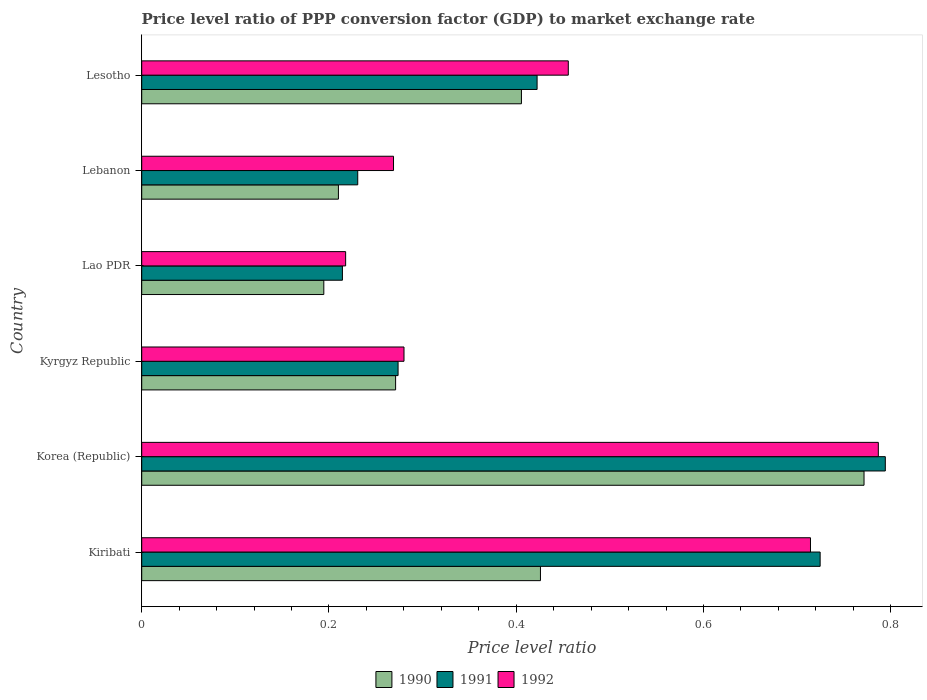How many different coloured bars are there?
Offer a terse response. 3. How many groups of bars are there?
Keep it short and to the point. 6. How many bars are there on the 3rd tick from the top?
Offer a terse response. 3. How many bars are there on the 1st tick from the bottom?
Give a very brief answer. 3. What is the label of the 6th group of bars from the top?
Offer a terse response. Kiribati. What is the price level ratio in 1992 in Lao PDR?
Keep it short and to the point. 0.22. Across all countries, what is the maximum price level ratio in 1992?
Ensure brevity in your answer.  0.79. Across all countries, what is the minimum price level ratio in 1991?
Your response must be concise. 0.21. In which country was the price level ratio in 1992 maximum?
Make the answer very short. Korea (Republic). In which country was the price level ratio in 1992 minimum?
Your answer should be very brief. Lao PDR. What is the total price level ratio in 1992 in the graph?
Offer a very short reply. 2.72. What is the difference between the price level ratio in 1990 in Lao PDR and that in Lesotho?
Give a very brief answer. -0.21. What is the difference between the price level ratio in 1992 in Kyrgyz Republic and the price level ratio in 1991 in Korea (Republic)?
Give a very brief answer. -0.51. What is the average price level ratio in 1991 per country?
Your answer should be compact. 0.44. What is the difference between the price level ratio in 1991 and price level ratio in 1992 in Lesotho?
Offer a very short reply. -0.03. What is the ratio of the price level ratio in 1992 in Kyrgyz Republic to that in Lebanon?
Your answer should be compact. 1.04. Is the price level ratio in 1991 in Kyrgyz Republic less than that in Lao PDR?
Your answer should be compact. No. Is the difference between the price level ratio in 1991 in Kyrgyz Republic and Lesotho greater than the difference between the price level ratio in 1992 in Kyrgyz Republic and Lesotho?
Your answer should be compact. Yes. What is the difference between the highest and the second highest price level ratio in 1990?
Provide a succinct answer. 0.35. What is the difference between the highest and the lowest price level ratio in 1990?
Offer a very short reply. 0.58. What does the 3rd bar from the bottom in Korea (Republic) represents?
Keep it short and to the point. 1992. How many bars are there?
Offer a terse response. 18. Are all the bars in the graph horizontal?
Give a very brief answer. Yes. How many countries are there in the graph?
Ensure brevity in your answer.  6. What is the difference between two consecutive major ticks on the X-axis?
Provide a succinct answer. 0.2. Does the graph contain any zero values?
Your answer should be compact. No. Does the graph contain grids?
Give a very brief answer. No. What is the title of the graph?
Provide a succinct answer. Price level ratio of PPP conversion factor (GDP) to market exchange rate. Does "1992" appear as one of the legend labels in the graph?
Your answer should be compact. Yes. What is the label or title of the X-axis?
Offer a very short reply. Price level ratio. What is the label or title of the Y-axis?
Your answer should be very brief. Country. What is the Price level ratio of 1990 in Kiribati?
Make the answer very short. 0.43. What is the Price level ratio of 1991 in Kiribati?
Offer a very short reply. 0.72. What is the Price level ratio in 1992 in Kiribati?
Give a very brief answer. 0.71. What is the Price level ratio of 1990 in Korea (Republic)?
Keep it short and to the point. 0.77. What is the Price level ratio in 1991 in Korea (Republic)?
Keep it short and to the point. 0.79. What is the Price level ratio in 1992 in Korea (Republic)?
Your response must be concise. 0.79. What is the Price level ratio in 1990 in Kyrgyz Republic?
Your answer should be very brief. 0.27. What is the Price level ratio of 1991 in Kyrgyz Republic?
Give a very brief answer. 0.27. What is the Price level ratio of 1992 in Kyrgyz Republic?
Provide a short and direct response. 0.28. What is the Price level ratio of 1990 in Lao PDR?
Provide a succinct answer. 0.19. What is the Price level ratio of 1991 in Lao PDR?
Provide a short and direct response. 0.21. What is the Price level ratio of 1992 in Lao PDR?
Your answer should be very brief. 0.22. What is the Price level ratio of 1990 in Lebanon?
Make the answer very short. 0.21. What is the Price level ratio of 1991 in Lebanon?
Ensure brevity in your answer.  0.23. What is the Price level ratio of 1992 in Lebanon?
Give a very brief answer. 0.27. What is the Price level ratio in 1990 in Lesotho?
Ensure brevity in your answer.  0.41. What is the Price level ratio in 1991 in Lesotho?
Offer a very short reply. 0.42. What is the Price level ratio of 1992 in Lesotho?
Provide a succinct answer. 0.46. Across all countries, what is the maximum Price level ratio in 1990?
Offer a terse response. 0.77. Across all countries, what is the maximum Price level ratio in 1991?
Keep it short and to the point. 0.79. Across all countries, what is the maximum Price level ratio in 1992?
Offer a very short reply. 0.79. Across all countries, what is the minimum Price level ratio in 1990?
Your response must be concise. 0.19. Across all countries, what is the minimum Price level ratio in 1991?
Keep it short and to the point. 0.21. Across all countries, what is the minimum Price level ratio of 1992?
Provide a succinct answer. 0.22. What is the total Price level ratio of 1990 in the graph?
Your answer should be compact. 2.28. What is the total Price level ratio in 1991 in the graph?
Ensure brevity in your answer.  2.66. What is the total Price level ratio of 1992 in the graph?
Your response must be concise. 2.72. What is the difference between the Price level ratio in 1990 in Kiribati and that in Korea (Republic)?
Offer a very short reply. -0.35. What is the difference between the Price level ratio in 1991 in Kiribati and that in Korea (Republic)?
Keep it short and to the point. -0.07. What is the difference between the Price level ratio in 1992 in Kiribati and that in Korea (Republic)?
Offer a very short reply. -0.07. What is the difference between the Price level ratio in 1990 in Kiribati and that in Kyrgyz Republic?
Ensure brevity in your answer.  0.15. What is the difference between the Price level ratio in 1991 in Kiribati and that in Kyrgyz Republic?
Make the answer very short. 0.45. What is the difference between the Price level ratio in 1992 in Kiribati and that in Kyrgyz Republic?
Offer a terse response. 0.43. What is the difference between the Price level ratio of 1990 in Kiribati and that in Lao PDR?
Your answer should be compact. 0.23. What is the difference between the Price level ratio of 1991 in Kiribati and that in Lao PDR?
Give a very brief answer. 0.51. What is the difference between the Price level ratio in 1992 in Kiribati and that in Lao PDR?
Keep it short and to the point. 0.5. What is the difference between the Price level ratio of 1990 in Kiribati and that in Lebanon?
Make the answer very short. 0.22. What is the difference between the Price level ratio in 1991 in Kiribati and that in Lebanon?
Provide a succinct answer. 0.49. What is the difference between the Price level ratio of 1992 in Kiribati and that in Lebanon?
Make the answer very short. 0.45. What is the difference between the Price level ratio of 1990 in Kiribati and that in Lesotho?
Your answer should be compact. 0.02. What is the difference between the Price level ratio in 1991 in Kiribati and that in Lesotho?
Provide a short and direct response. 0.3. What is the difference between the Price level ratio in 1992 in Kiribati and that in Lesotho?
Your response must be concise. 0.26. What is the difference between the Price level ratio of 1990 in Korea (Republic) and that in Kyrgyz Republic?
Your answer should be very brief. 0.5. What is the difference between the Price level ratio of 1991 in Korea (Republic) and that in Kyrgyz Republic?
Provide a short and direct response. 0.52. What is the difference between the Price level ratio of 1992 in Korea (Republic) and that in Kyrgyz Republic?
Give a very brief answer. 0.51. What is the difference between the Price level ratio in 1990 in Korea (Republic) and that in Lao PDR?
Your response must be concise. 0.58. What is the difference between the Price level ratio in 1991 in Korea (Republic) and that in Lao PDR?
Your answer should be very brief. 0.58. What is the difference between the Price level ratio of 1992 in Korea (Republic) and that in Lao PDR?
Make the answer very short. 0.57. What is the difference between the Price level ratio in 1990 in Korea (Republic) and that in Lebanon?
Offer a terse response. 0.56. What is the difference between the Price level ratio of 1991 in Korea (Republic) and that in Lebanon?
Your answer should be very brief. 0.56. What is the difference between the Price level ratio of 1992 in Korea (Republic) and that in Lebanon?
Ensure brevity in your answer.  0.52. What is the difference between the Price level ratio of 1990 in Korea (Republic) and that in Lesotho?
Provide a short and direct response. 0.37. What is the difference between the Price level ratio in 1991 in Korea (Republic) and that in Lesotho?
Ensure brevity in your answer.  0.37. What is the difference between the Price level ratio in 1992 in Korea (Republic) and that in Lesotho?
Offer a terse response. 0.33. What is the difference between the Price level ratio in 1990 in Kyrgyz Republic and that in Lao PDR?
Your answer should be very brief. 0.08. What is the difference between the Price level ratio in 1991 in Kyrgyz Republic and that in Lao PDR?
Your answer should be compact. 0.06. What is the difference between the Price level ratio in 1992 in Kyrgyz Republic and that in Lao PDR?
Keep it short and to the point. 0.06. What is the difference between the Price level ratio in 1990 in Kyrgyz Republic and that in Lebanon?
Offer a very short reply. 0.06. What is the difference between the Price level ratio of 1991 in Kyrgyz Republic and that in Lebanon?
Offer a very short reply. 0.04. What is the difference between the Price level ratio of 1992 in Kyrgyz Republic and that in Lebanon?
Offer a very short reply. 0.01. What is the difference between the Price level ratio of 1990 in Kyrgyz Republic and that in Lesotho?
Make the answer very short. -0.13. What is the difference between the Price level ratio in 1991 in Kyrgyz Republic and that in Lesotho?
Offer a very short reply. -0.15. What is the difference between the Price level ratio of 1992 in Kyrgyz Republic and that in Lesotho?
Make the answer very short. -0.18. What is the difference between the Price level ratio in 1990 in Lao PDR and that in Lebanon?
Your answer should be compact. -0.02. What is the difference between the Price level ratio in 1991 in Lao PDR and that in Lebanon?
Ensure brevity in your answer.  -0.02. What is the difference between the Price level ratio of 1992 in Lao PDR and that in Lebanon?
Offer a very short reply. -0.05. What is the difference between the Price level ratio of 1990 in Lao PDR and that in Lesotho?
Provide a succinct answer. -0.21. What is the difference between the Price level ratio in 1991 in Lao PDR and that in Lesotho?
Keep it short and to the point. -0.21. What is the difference between the Price level ratio of 1992 in Lao PDR and that in Lesotho?
Provide a short and direct response. -0.24. What is the difference between the Price level ratio of 1990 in Lebanon and that in Lesotho?
Give a very brief answer. -0.2. What is the difference between the Price level ratio in 1991 in Lebanon and that in Lesotho?
Provide a short and direct response. -0.19. What is the difference between the Price level ratio in 1992 in Lebanon and that in Lesotho?
Provide a succinct answer. -0.19. What is the difference between the Price level ratio of 1990 in Kiribati and the Price level ratio of 1991 in Korea (Republic)?
Give a very brief answer. -0.37. What is the difference between the Price level ratio in 1990 in Kiribati and the Price level ratio in 1992 in Korea (Republic)?
Offer a very short reply. -0.36. What is the difference between the Price level ratio of 1991 in Kiribati and the Price level ratio of 1992 in Korea (Republic)?
Offer a very short reply. -0.06. What is the difference between the Price level ratio of 1990 in Kiribati and the Price level ratio of 1991 in Kyrgyz Republic?
Your answer should be very brief. 0.15. What is the difference between the Price level ratio of 1990 in Kiribati and the Price level ratio of 1992 in Kyrgyz Republic?
Your response must be concise. 0.15. What is the difference between the Price level ratio in 1991 in Kiribati and the Price level ratio in 1992 in Kyrgyz Republic?
Ensure brevity in your answer.  0.44. What is the difference between the Price level ratio of 1990 in Kiribati and the Price level ratio of 1991 in Lao PDR?
Provide a succinct answer. 0.21. What is the difference between the Price level ratio in 1990 in Kiribati and the Price level ratio in 1992 in Lao PDR?
Your answer should be compact. 0.21. What is the difference between the Price level ratio in 1991 in Kiribati and the Price level ratio in 1992 in Lao PDR?
Give a very brief answer. 0.51. What is the difference between the Price level ratio of 1990 in Kiribati and the Price level ratio of 1991 in Lebanon?
Keep it short and to the point. 0.2. What is the difference between the Price level ratio of 1990 in Kiribati and the Price level ratio of 1992 in Lebanon?
Keep it short and to the point. 0.16. What is the difference between the Price level ratio of 1991 in Kiribati and the Price level ratio of 1992 in Lebanon?
Provide a succinct answer. 0.46. What is the difference between the Price level ratio in 1990 in Kiribati and the Price level ratio in 1991 in Lesotho?
Your response must be concise. 0. What is the difference between the Price level ratio of 1990 in Kiribati and the Price level ratio of 1992 in Lesotho?
Your answer should be compact. -0.03. What is the difference between the Price level ratio in 1991 in Kiribati and the Price level ratio in 1992 in Lesotho?
Make the answer very short. 0.27. What is the difference between the Price level ratio in 1990 in Korea (Republic) and the Price level ratio in 1991 in Kyrgyz Republic?
Provide a short and direct response. 0.5. What is the difference between the Price level ratio in 1990 in Korea (Republic) and the Price level ratio in 1992 in Kyrgyz Republic?
Your answer should be very brief. 0.49. What is the difference between the Price level ratio of 1991 in Korea (Republic) and the Price level ratio of 1992 in Kyrgyz Republic?
Provide a succinct answer. 0.51. What is the difference between the Price level ratio of 1990 in Korea (Republic) and the Price level ratio of 1991 in Lao PDR?
Make the answer very short. 0.56. What is the difference between the Price level ratio of 1990 in Korea (Republic) and the Price level ratio of 1992 in Lao PDR?
Your answer should be very brief. 0.55. What is the difference between the Price level ratio in 1991 in Korea (Republic) and the Price level ratio in 1992 in Lao PDR?
Offer a terse response. 0.58. What is the difference between the Price level ratio of 1990 in Korea (Republic) and the Price level ratio of 1991 in Lebanon?
Give a very brief answer. 0.54. What is the difference between the Price level ratio of 1990 in Korea (Republic) and the Price level ratio of 1992 in Lebanon?
Keep it short and to the point. 0.5. What is the difference between the Price level ratio of 1991 in Korea (Republic) and the Price level ratio of 1992 in Lebanon?
Your answer should be very brief. 0.53. What is the difference between the Price level ratio of 1990 in Korea (Republic) and the Price level ratio of 1991 in Lesotho?
Give a very brief answer. 0.35. What is the difference between the Price level ratio in 1990 in Korea (Republic) and the Price level ratio in 1992 in Lesotho?
Your answer should be compact. 0.32. What is the difference between the Price level ratio in 1991 in Korea (Republic) and the Price level ratio in 1992 in Lesotho?
Offer a terse response. 0.34. What is the difference between the Price level ratio in 1990 in Kyrgyz Republic and the Price level ratio in 1991 in Lao PDR?
Keep it short and to the point. 0.06. What is the difference between the Price level ratio of 1990 in Kyrgyz Republic and the Price level ratio of 1992 in Lao PDR?
Your response must be concise. 0.05. What is the difference between the Price level ratio in 1991 in Kyrgyz Republic and the Price level ratio in 1992 in Lao PDR?
Keep it short and to the point. 0.06. What is the difference between the Price level ratio of 1990 in Kyrgyz Republic and the Price level ratio of 1991 in Lebanon?
Give a very brief answer. 0.04. What is the difference between the Price level ratio of 1990 in Kyrgyz Republic and the Price level ratio of 1992 in Lebanon?
Make the answer very short. 0. What is the difference between the Price level ratio of 1991 in Kyrgyz Republic and the Price level ratio of 1992 in Lebanon?
Offer a very short reply. 0. What is the difference between the Price level ratio of 1990 in Kyrgyz Republic and the Price level ratio of 1991 in Lesotho?
Keep it short and to the point. -0.15. What is the difference between the Price level ratio of 1990 in Kyrgyz Republic and the Price level ratio of 1992 in Lesotho?
Provide a succinct answer. -0.18. What is the difference between the Price level ratio in 1991 in Kyrgyz Republic and the Price level ratio in 1992 in Lesotho?
Provide a short and direct response. -0.18. What is the difference between the Price level ratio of 1990 in Lao PDR and the Price level ratio of 1991 in Lebanon?
Provide a short and direct response. -0.04. What is the difference between the Price level ratio in 1990 in Lao PDR and the Price level ratio in 1992 in Lebanon?
Provide a succinct answer. -0.07. What is the difference between the Price level ratio in 1991 in Lao PDR and the Price level ratio in 1992 in Lebanon?
Your answer should be very brief. -0.05. What is the difference between the Price level ratio of 1990 in Lao PDR and the Price level ratio of 1991 in Lesotho?
Keep it short and to the point. -0.23. What is the difference between the Price level ratio of 1990 in Lao PDR and the Price level ratio of 1992 in Lesotho?
Offer a very short reply. -0.26. What is the difference between the Price level ratio of 1991 in Lao PDR and the Price level ratio of 1992 in Lesotho?
Your answer should be compact. -0.24. What is the difference between the Price level ratio in 1990 in Lebanon and the Price level ratio in 1991 in Lesotho?
Offer a terse response. -0.21. What is the difference between the Price level ratio of 1990 in Lebanon and the Price level ratio of 1992 in Lesotho?
Offer a very short reply. -0.25. What is the difference between the Price level ratio of 1991 in Lebanon and the Price level ratio of 1992 in Lesotho?
Offer a very short reply. -0.22. What is the average Price level ratio in 1990 per country?
Provide a short and direct response. 0.38. What is the average Price level ratio of 1991 per country?
Provide a succinct answer. 0.44. What is the average Price level ratio of 1992 per country?
Provide a short and direct response. 0.45. What is the difference between the Price level ratio in 1990 and Price level ratio in 1991 in Kiribati?
Your answer should be very brief. -0.3. What is the difference between the Price level ratio of 1990 and Price level ratio of 1992 in Kiribati?
Offer a terse response. -0.29. What is the difference between the Price level ratio in 1991 and Price level ratio in 1992 in Kiribati?
Your response must be concise. 0.01. What is the difference between the Price level ratio of 1990 and Price level ratio of 1991 in Korea (Republic)?
Offer a terse response. -0.02. What is the difference between the Price level ratio of 1990 and Price level ratio of 1992 in Korea (Republic)?
Your answer should be very brief. -0.02. What is the difference between the Price level ratio of 1991 and Price level ratio of 1992 in Korea (Republic)?
Provide a succinct answer. 0.01. What is the difference between the Price level ratio of 1990 and Price level ratio of 1991 in Kyrgyz Republic?
Offer a very short reply. -0. What is the difference between the Price level ratio of 1990 and Price level ratio of 1992 in Kyrgyz Republic?
Make the answer very short. -0.01. What is the difference between the Price level ratio in 1991 and Price level ratio in 1992 in Kyrgyz Republic?
Offer a terse response. -0.01. What is the difference between the Price level ratio of 1990 and Price level ratio of 1991 in Lao PDR?
Make the answer very short. -0.02. What is the difference between the Price level ratio of 1990 and Price level ratio of 1992 in Lao PDR?
Your answer should be very brief. -0.02. What is the difference between the Price level ratio in 1991 and Price level ratio in 1992 in Lao PDR?
Your response must be concise. -0. What is the difference between the Price level ratio in 1990 and Price level ratio in 1991 in Lebanon?
Make the answer very short. -0.02. What is the difference between the Price level ratio of 1990 and Price level ratio of 1992 in Lebanon?
Make the answer very short. -0.06. What is the difference between the Price level ratio in 1991 and Price level ratio in 1992 in Lebanon?
Give a very brief answer. -0.04. What is the difference between the Price level ratio of 1990 and Price level ratio of 1991 in Lesotho?
Your response must be concise. -0.02. What is the difference between the Price level ratio in 1991 and Price level ratio in 1992 in Lesotho?
Provide a short and direct response. -0.03. What is the ratio of the Price level ratio in 1990 in Kiribati to that in Korea (Republic)?
Ensure brevity in your answer.  0.55. What is the ratio of the Price level ratio in 1991 in Kiribati to that in Korea (Republic)?
Provide a short and direct response. 0.91. What is the ratio of the Price level ratio of 1992 in Kiribati to that in Korea (Republic)?
Your answer should be very brief. 0.91. What is the ratio of the Price level ratio of 1990 in Kiribati to that in Kyrgyz Republic?
Offer a very short reply. 1.57. What is the ratio of the Price level ratio of 1991 in Kiribati to that in Kyrgyz Republic?
Your answer should be compact. 2.65. What is the ratio of the Price level ratio in 1992 in Kiribati to that in Kyrgyz Republic?
Your response must be concise. 2.55. What is the ratio of the Price level ratio in 1990 in Kiribati to that in Lao PDR?
Offer a very short reply. 2.19. What is the ratio of the Price level ratio of 1991 in Kiribati to that in Lao PDR?
Your answer should be very brief. 3.38. What is the ratio of the Price level ratio in 1992 in Kiribati to that in Lao PDR?
Offer a terse response. 3.28. What is the ratio of the Price level ratio in 1990 in Kiribati to that in Lebanon?
Keep it short and to the point. 2.03. What is the ratio of the Price level ratio in 1991 in Kiribati to that in Lebanon?
Ensure brevity in your answer.  3.14. What is the ratio of the Price level ratio in 1992 in Kiribati to that in Lebanon?
Offer a terse response. 2.66. What is the ratio of the Price level ratio of 1990 in Kiribati to that in Lesotho?
Your response must be concise. 1.05. What is the ratio of the Price level ratio in 1991 in Kiribati to that in Lesotho?
Your response must be concise. 1.72. What is the ratio of the Price level ratio of 1992 in Kiribati to that in Lesotho?
Keep it short and to the point. 1.57. What is the ratio of the Price level ratio in 1990 in Korea (Republic) to that in Kyrgyz Republic?
Provide a short and direct response. 2.85. What is the ratio of the Price level ratio of 1991 in Korea (Republic) to that in Kyrgyz Republic?
Make the answer very short. 2.9. What is the ratio of the Price level ratio of 1992 in Korea (Republic) to that in Kyrgyz Republic?
Give a very brief answer. 2.81. What is the ratio of the Price level ratio in 1990 in Korea (Republic) to that in Lao PDR?
Provide a succinct answer. 3.97. What is the ratio of the Price level ratio in 1991 in Korea (Republic) to that in Lao PDR?
Your answer should be very brief. 3.71. What is the ratio of the Price level ratio in 1992 in Korea (Republic) to that in Lao PDR?
Your response must be concise. 3.61. What is the ratio of the Price level ratio of 1990 in Korea (Republic) to that in Lebanon?
Offer a very short reply. 3.67. What is the ratio of the Price level ratio in 1991 in Korea (Republic) to that in Lebanon?
Your answer should be very brief. 3.44. What is the ratio of the Price level ratio of 1992 in Korea (Republic) to that in Lebanon?
Give a very brief answer. 2.93. What is the ratio of the Price level ratio in 1990 in Korea (Republic) to that in Lesotho?
Provide a succinct answer. 1.9. What is the ratio of the Price level ratio in 1991 in Korea (Republic) to that in Lesotho?
Provide a short and direct response. 1.88. What is the ratio of the Price level ratio of 1992 in Korea (Republic) to that in Lesotho?
Your response must be concise. 1.73. What is the ratio of the Price level ratio in 1990 in Kyrgyz Republic to that in Lao PDR?
Provide a short and direct response. 1.39. What is the ratio of the Price level ratio of 1991 in Kyrgyz Republic to that in Lao PDR?
Give a very brief answer. 1.28. What is the ratio of the Price level ratio of 1992 in Kyrgyz Republic to that in Lao PDR?
Your response must be concise. 1.29. What is the ratio of the Price level ratio in 1990 in Kyrgyz Republic to that in Lebanon?
Your answer should be compact. 1.29. What is the ratio of the Price level ratio in 1991 in Kyrgyz Republic to that in Lebanon?
Offer a very short reply. 1.19. What is the ratio of the Price level ratio in 1992 in Kyrgyz Republic to that in Lebanon?
Make the answer very short. 1.04. What is the ratio of the Price level ratio in 1990 in Kyrgyz Republic to that in Lesotho?
Offer a terse response. 0.67. What is the ratio of the Price level ratio in 1991 in Kyrgyz Republic to that in Lesotho?
Your answer should be very brief. 0.65. What is the ratio of the Price level ratio in 1992 in Kyrgyz Republic to that in Lesotho?
Ensure brevity in your answer.  0.61. What is the ratio of the Price level ratio in 1990 in Lao PDR to that in Lebanon?
Your answer should be compact. 0.93. What is the ratio of the Price level ratio of 1991 in Lao PDR to that in Lebanon?
Offer a very short reply. 0.93. What is the ratio of the Price level ratio in 1992 in Lao PDR to that in Lebanon?
Offer a terse response. 0.81. What is the ratio of the Price level ratio of 1990 in Lao PDR to that in Lesotho?
Offer a very short reply. 0.48. What is the ratio of the Price level ratio in 1991 in Lao PDR to that in Lesotho?
Make the answer very short. 0.51. What is the ratio of the Price level ratio of 1992 in Lao PDR to that in Lesotho?
Provide a succinct answer. 0.48. What is the ratio of the Price level ratio in 1990 in Lebanon to that in Lesotho?
Your answer should be compact. 0.52. What is the ratio of the Price level ratio of 1991 in Lebanon to that in Lesotho?
Provide a succinct answer. 0.55. What is the ratio of the Price level ratio in 1992 in Lebanon to that in Lesotho?
Give a very brief answer. 0.59. What is the difference between the highest and the second highest Price level ratio of 1990?
Your response must be concise. 0.35. What is the difference between the highest and the second highest Price level ratio of 1991?
Offer a terse response. 0.07. What is the difference between the highest and the second highest Price level ratio in 1992?
Ensure brevity in your answer.  0.07. What is the difference between the highest and the lowest Price level ratio of 1990?
Offer a very short reply. 0.58. What is the difference between the highest and the lowest Price level ratio of 1991?
Your answer should be very brief. 0.58. What is the difference between the highest and the lowest Price level ratio of 1992?
Offer a very short reply. 0.57. 